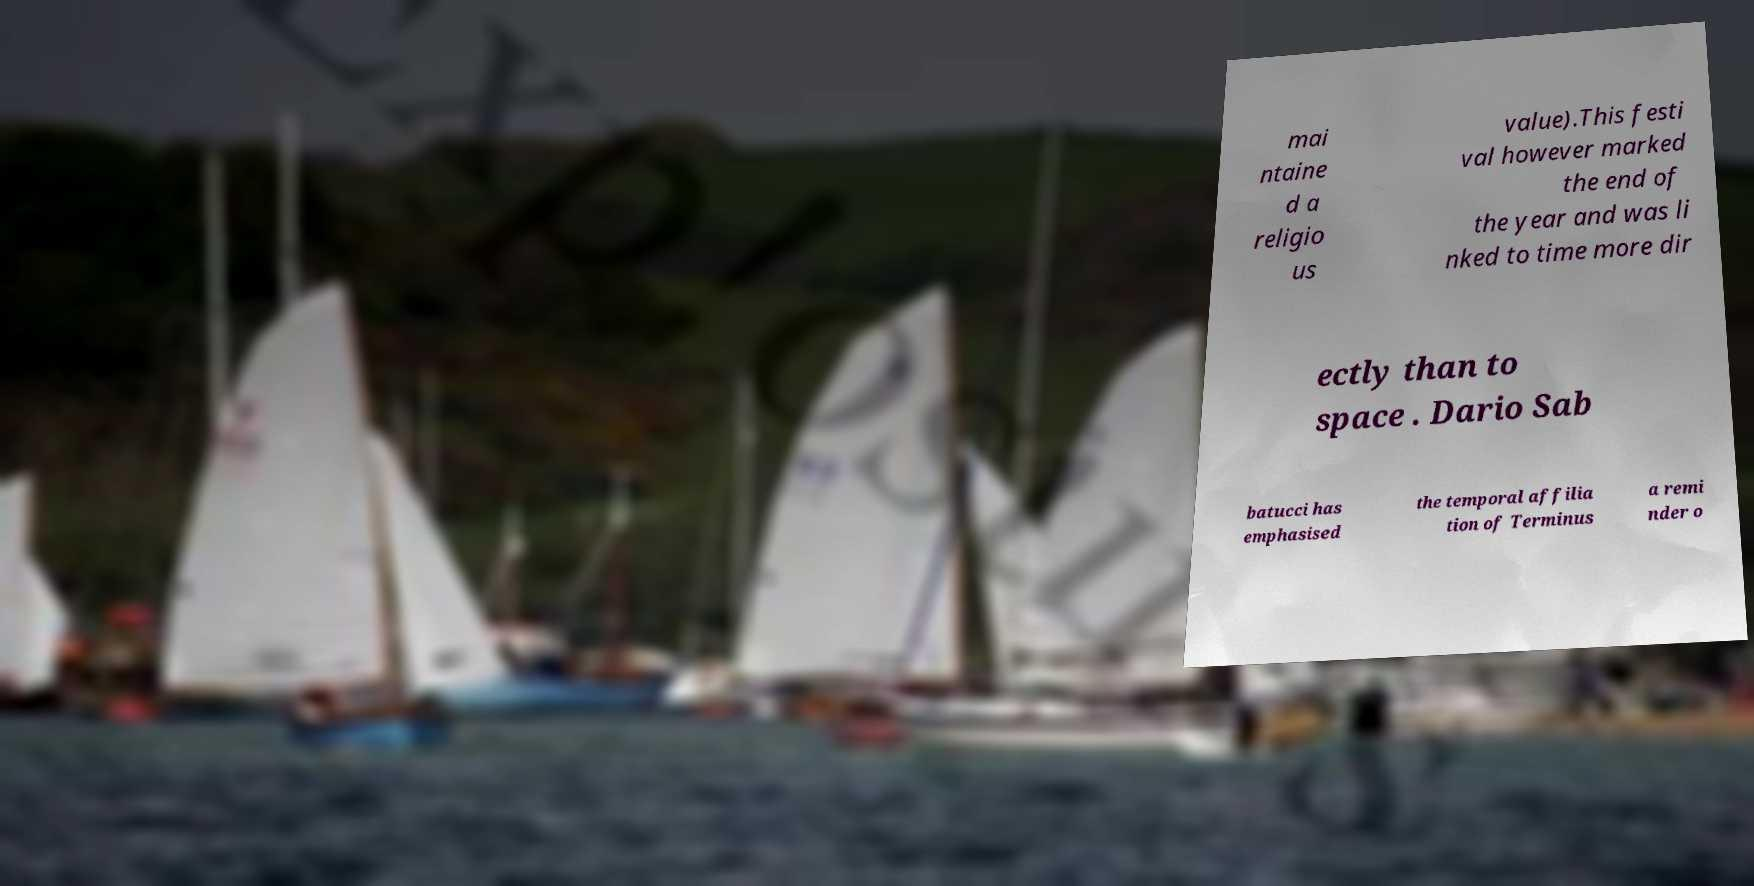There's text embedded in this image that I need extracted. Can you transcribe it verbatim? mai ntaine d a religio us value).This festi val however marked the end of the year and was li nked to time more dir ectly than to space . Dario Sab batucci has emphasised the temporal affilia tion of Terminus a remi nder o 